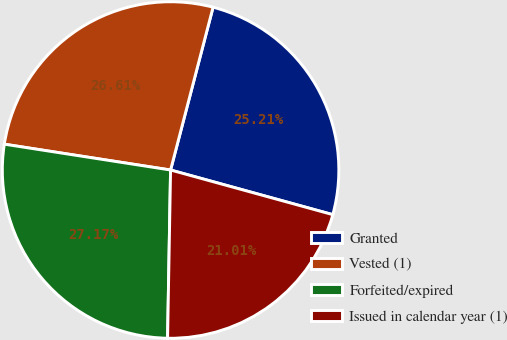Convert chart. <chart><loc_0><loc_0><loc_500><loc_500><pie_chart><fcel>Granted<fcel>Vested (1)<fcel>Forfeited/expired<fcel>Issued in calendar year (1)<nl><fcel>25.21%<fcel>26.61%<fcel>27.17%<fcel>21.01%<nl></chart> 